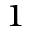Convert formula to latex. <formula><loc_0><loc_0><loc_500><loc_500>^ { 1 }</formula> 